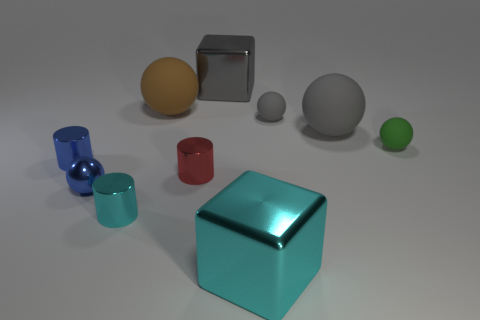Is there a metal cylinder that has the same color as the metallic sphere?
Provide a short and direct response. Yes. Does the big sphere that is to the right of the tiny red cylinder have the same material as the green thing?
Offer a very short reply. Yes. What size is the object that is both behind the tiny cyan shiny object and in front of the tiny red shiny thing?
Ensure brevity in your answer.  Small. Is the number of cyan cubes that are in front of the green matte object greater than the number of large blocks left of the brown rubber thing?
Ensure brevity in your answer.  Yes. There is a metallic cylinder that is the same color as the small metallic ball; what size is it?
Provide a short and direct response. Small. What color is the big object that is right of the big brown thing and behind the tiny gray matte thing?
Your answer should be very brief. Gray. What color is the shiny ball that is the same size as the blue metal cylinder?
Your answer should be very brief. Blue. There is a big matte object that is left of the cyan shiny object that is to the right of the big metal object that is behind the tiny metallic ball; what is its shape?
Your response must be concise. Sphere. How many things are either big metal balls or small shiny cylinders that are in front of the blue sphere?
Offer a very short reply. 1. Is the size of the brown matte ball that is to the right of the blue cylinder the same as the small green matte object?
Ensure brevity in your answer.  No. 